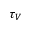<formula> <loc_0><loc_0><loc_500><loc_500>\tau _ { V }</formula> 